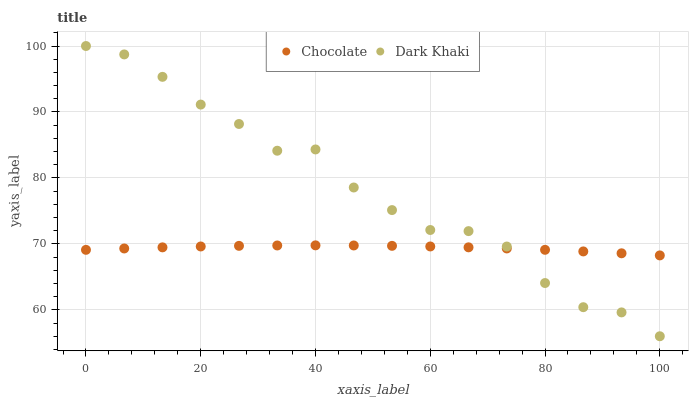Does Chocolate have the minimum area under the curve?
Answer yes or no. Yes. Does Dark Khaki have the maximum area under the curve?
Answer yes or no. Yes. Does Chocolate have the maximum area under the curve?
Answer yes or no. No. Is Chocolate the smoothest?
Answer yes or no. Yes. Is Dark Khaki the roughest?
Answer yes or no. Yes. Is Chocolate the roughest?
Answer yes or no. No. Does Dark Khaki have the lowest value?
Answer yes or no. Yes. Does Chocolate have the lowest value?
Answer yes or no. No. Does Dark Khaki have the highest value?
Answer yes or no. Yes. Does Chocolate have the highest value?
Answer yes or no. No. Does Chocolate intersect Dark Khaki?
Answer yes or no. Yes. Is Chocolate less than Dark Khaki?
Answer yes or no. No. Is Chocolate greater than Dark Khaki?
Answer yes or no. No. 